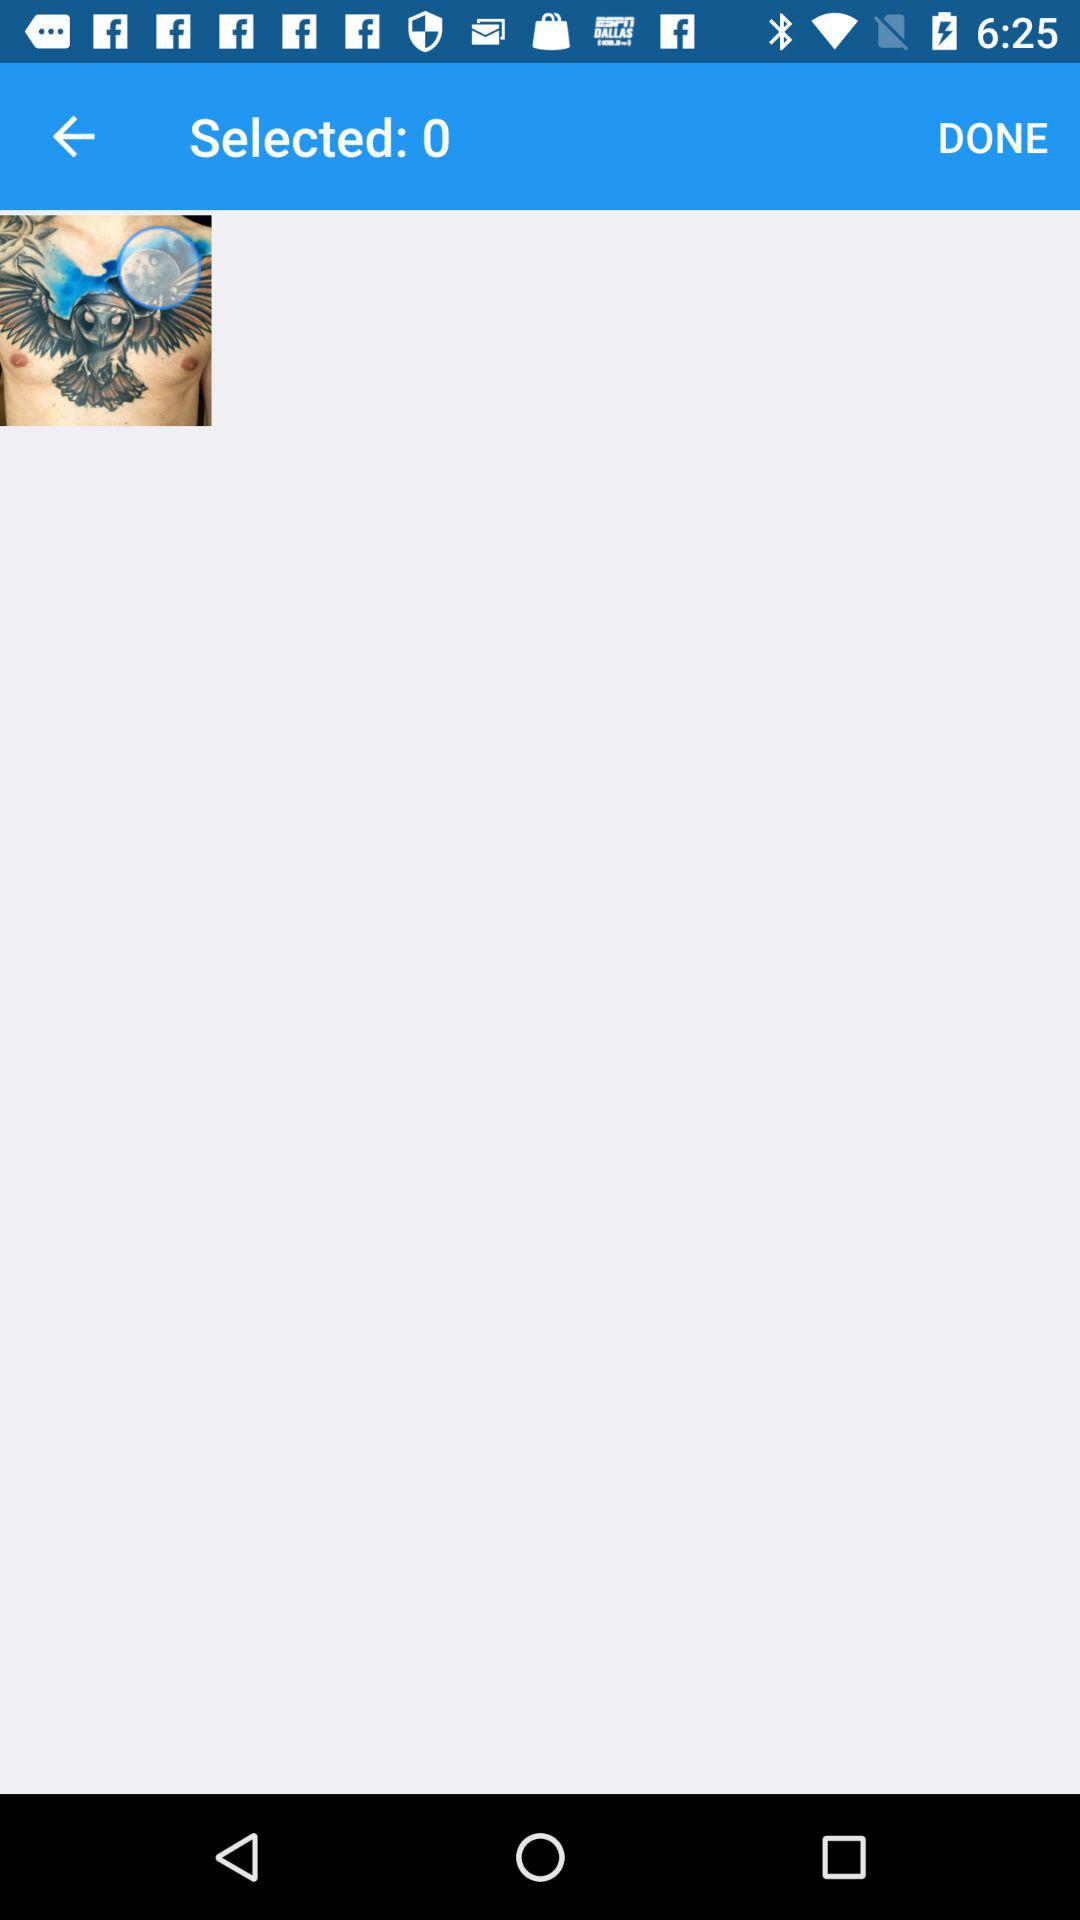What is the count for "Selected"? The count is 0. 